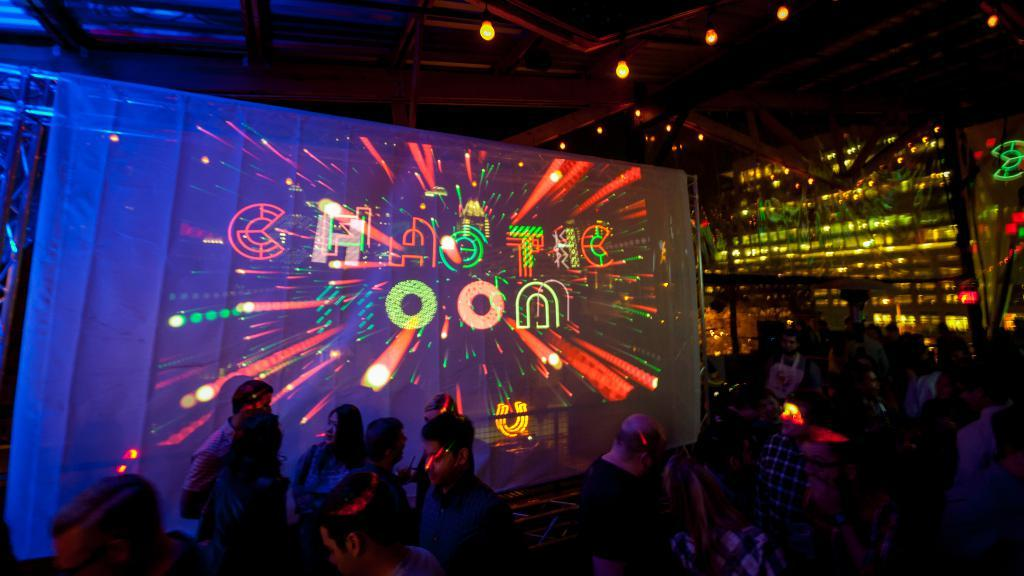<image>
Present a compact description of the photo's key features. A crowd dances at a club called the Chaotic Moon 